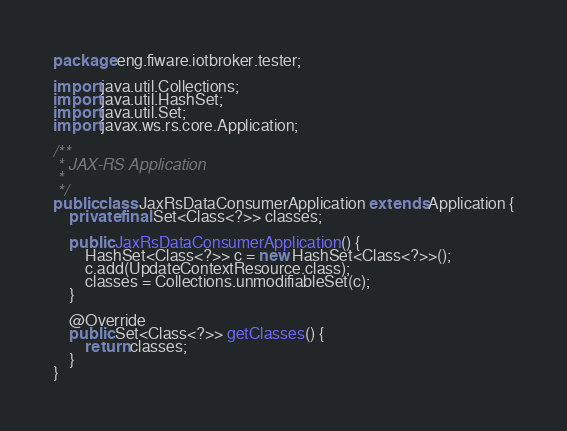Convert code to text. <code><loc_0><loc_0><loc_500><loc_500><_Java_>package eng.fiware.iotbroker.tester;

import java.util.Collections;
import java.util.HashSet;
import java.util.Set;
import javax.ws.rs.core.Application;

/**
 * JAX-RS Application
 *
 */
public class JaxRsDataConsumerApplication extends Application {
    private final Set<Class<?>> classes;

    public JaxRsDataConsumerApplication() {
        HashSet<Class<?>> c = new HashSet<Class<?>>();
		c.add(UpdateContextResource.class);
        classes = Collections.unmodifiableSet(c);
    }

    @Override
    public Set<Class<?>> getClasses() {
        return classes;
    }
}
</code> 